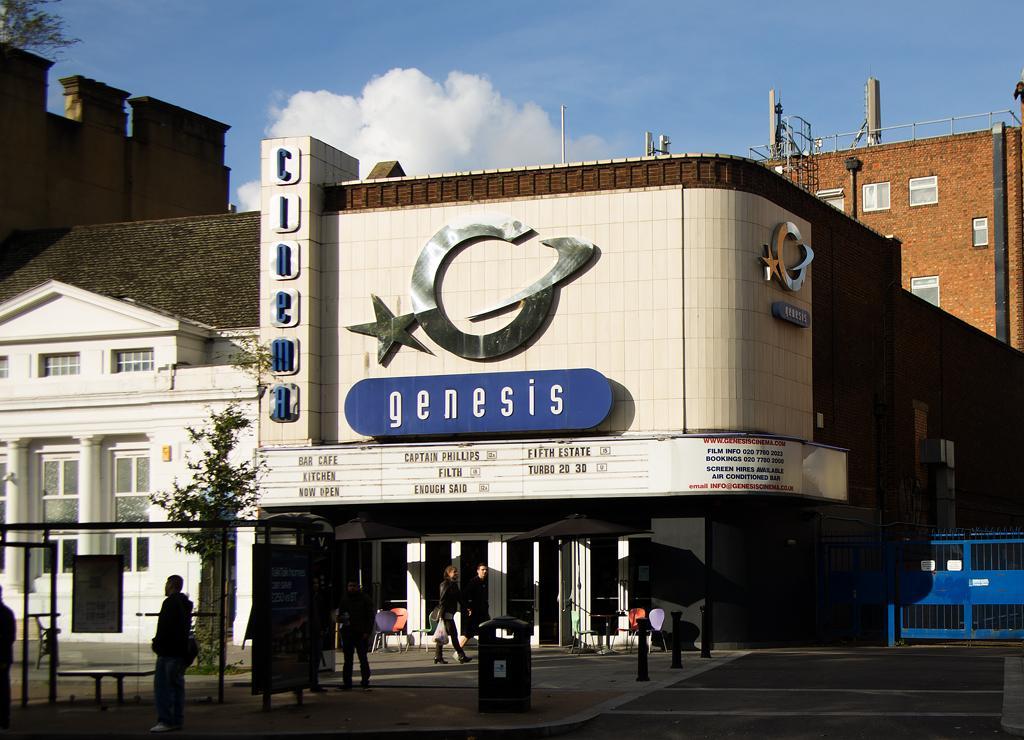How would you summarize this image in a sentence or two? In this picture there are people and we can see bin, boards, bench, shed and road. We can see buildings, poles, fence, poles and plant. In the background of the image we can see the sky with clouds and leaves. 